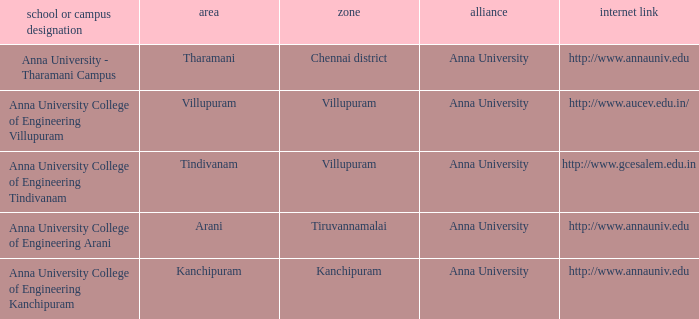What District has a Location of villupuram? Villupuram. 